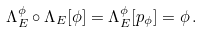<formula> <loc_0><loc_0><loc_500><loc_500>\Lambda _ { E } ^ { \phi } \circ \Lambda _ { E } [ \phi ] = \Lambda _ { E } ^ { \phi } [ p _ { \phi } ] = \phi \, .</formula> 